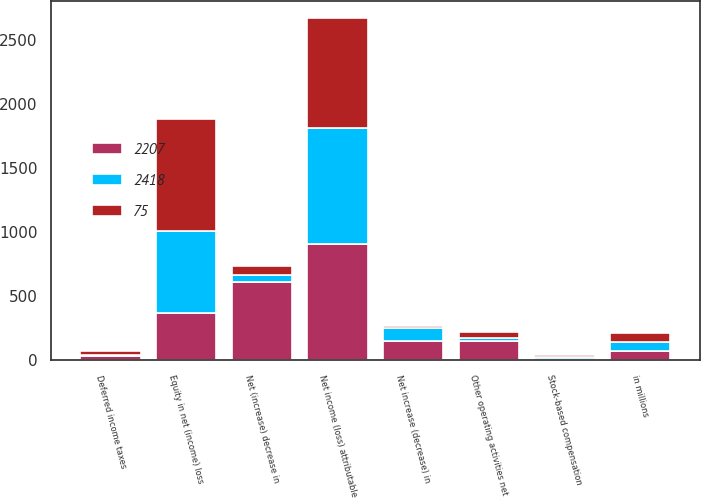Convert chart to OTSL. <chart><loc_0><loc_0><loc_500><loc_500><stacked_bar_chart><ecel><fcel>in millions<fcel>Net income (loss) attributable<fcel>Deferred income taxes<fcel>Stock-based compensation<fcel>Equity in net (income) loss<fcel>Net (increase) decrease in<fcel>Net increase (decrease) in<fcel>Other operating activities net<nl><fcel>2418<fcel>72<fcel>900<fcel>8<fcel>14<fcel>634<fcel>53<fcel>98<fcel>24<nl><fcel>2207<fcel>72<fcel>910<fcel>37<fcel>11<fcel>374<fcel>612<fcel>154<fcel>151<nl><fcel>75<fcel>72<fcel>858<fcel>32<fcel>17<fcel>877<fcel>72<fcel>16<fcel>50<nl></chart> 